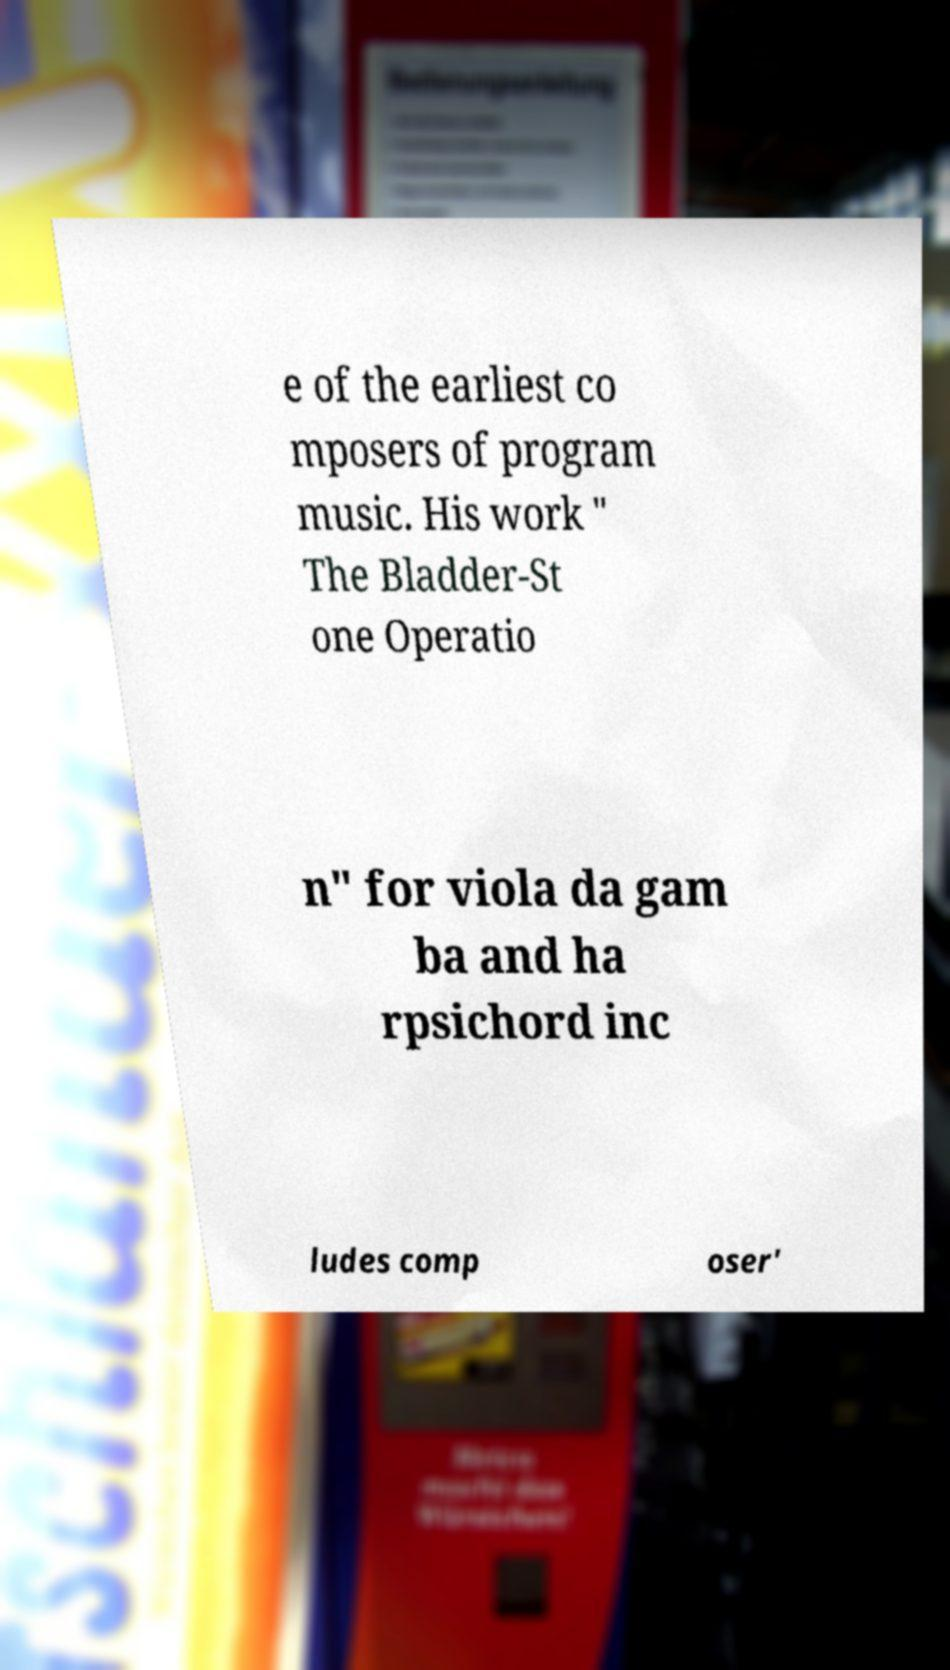Please read and relay the text visible in this image. What does it say? e of the earliest co mposers of program music. His work " The Bladder-St one Operatio n" for viola da gam ba and ha rpsichord inc ludes comp oser' 